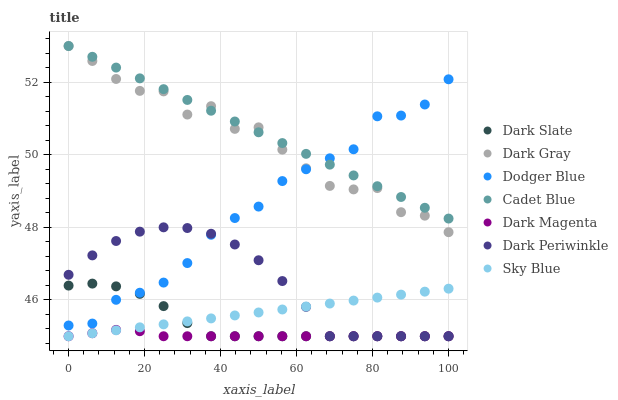Does Dark Magenta have the minimum area under the curve?
Answer yes or no. Yes. Does Cadet Blue have the maximum area under the curve?
Answer yes or no. Yes. Does Dark Gray have the minimum area under the curve?
Answer yes or no. No. Does Dark Gray have the maximum area under the curve?
Answer yes or no. No. Is Cadet Blue the smoothest?
Answer yes or no. Yes. Is Dark Gray the roughest?
Answer yes or no. Yes. Is Dark Magenta the smoothest?
Answer yes or no. No. Is Dark Magenta the roughest?
Answer yes or no. No. Does Dark Magenta have the lowest value?
Answer yes or no. Yes. Does Dark Gray have the lowest value?
Answer yes or no. No. Does Dark Gray have the highest value?
Answer yes or no. Yes. Does Dark Magenta have the highest value?
Answer yes or no. No. Is Dark Magenta less than Dark Gray?
Answer yes or no. Yes. Is Cadet Blue greater than Dark Magenta?
Answer yes or no. Yes. Does Dodger Blue intersect Dark Slate?
Answer yes or no. Yes. Is Dodger Blue less than Dark Slate?
Answer yes or no. No. Is Dodger Blue greater than Dark Slate?
Answer yes or no. No. Does Dark Magenta intersect Dark Gray?
Answer yes or no. No. 